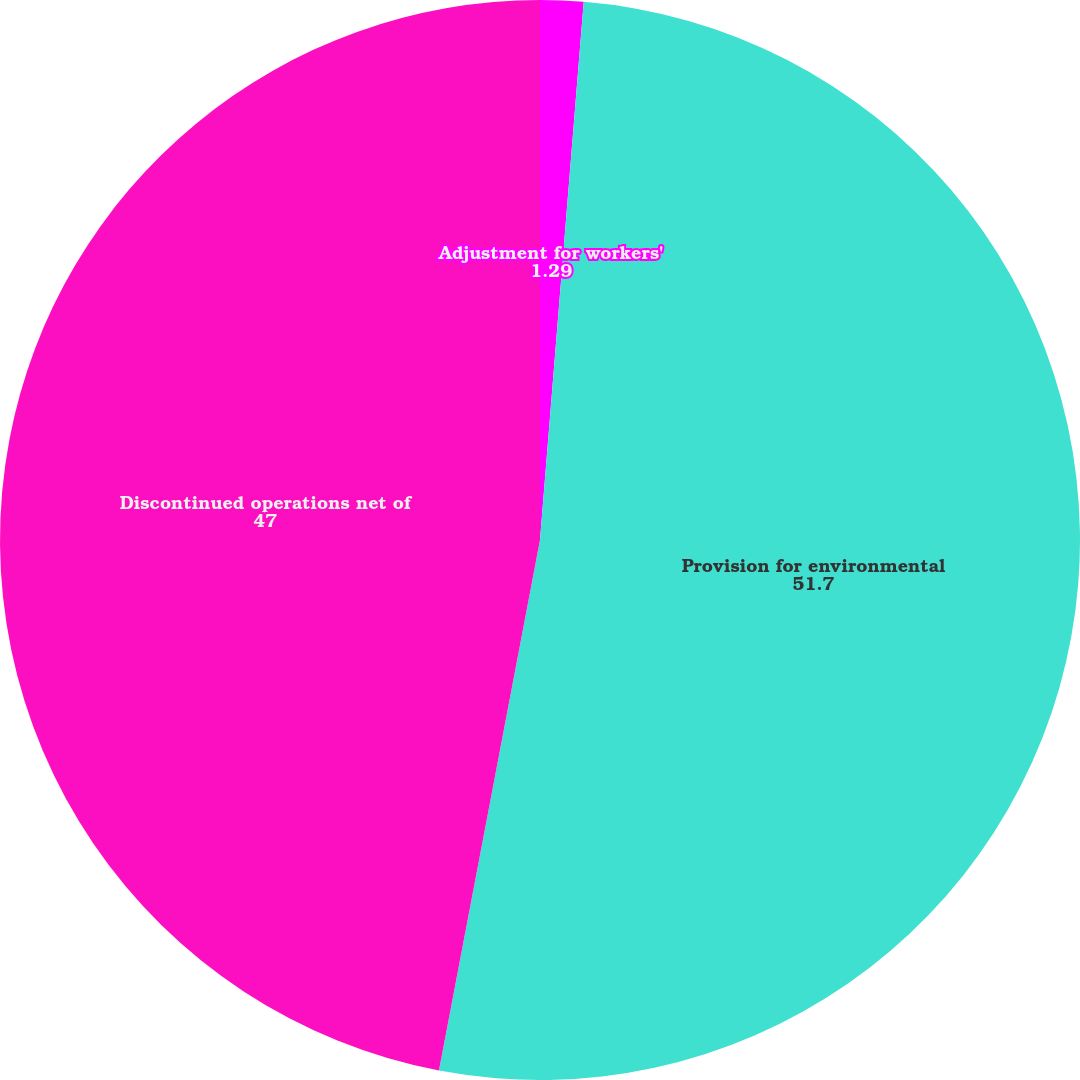<chart> <loc_0><loc_0><loc_500><loc_500><pie_chart><fcel>Adjustment for workers'<fcel>Provision for environmental<fcel>Discontinued operations net of<nl><fcel>1.29%<fcel>51.7%<fcel>47.0%<nl></chart> 